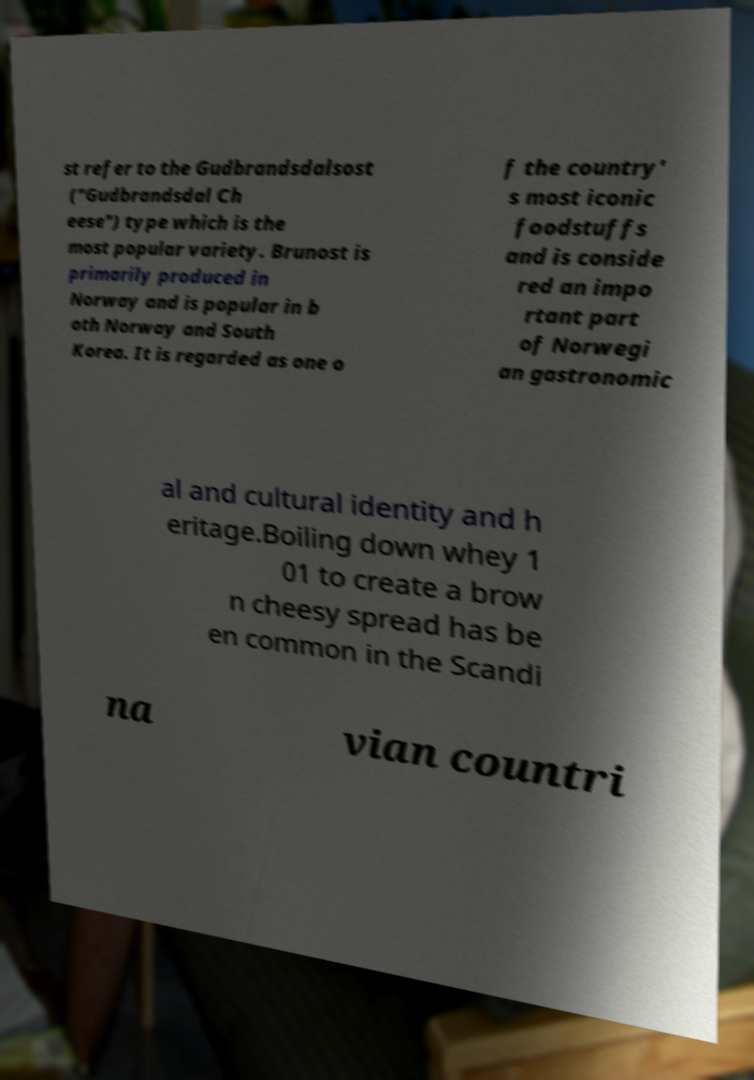Can you read and provide the text displayed in the image?This photo seems to have some interesting text. Can you extract and type it out for me? st refer to the Gudbrandsdalsost ("Gudbrandsdal Ch eese") type which is the most popular variety. Brunost is primarily produced in Norway and is popular in b oth Norway and South Korea. It is regarded as one o f the country' s most iconic foodstuffs and is conside red an impo rtant part of Norwegi an gastronomic al and cultural identity and h eritage.Boiling down whey 1 01 to create a brow n cheesy spread has be en common in the Scandi na vian countri 